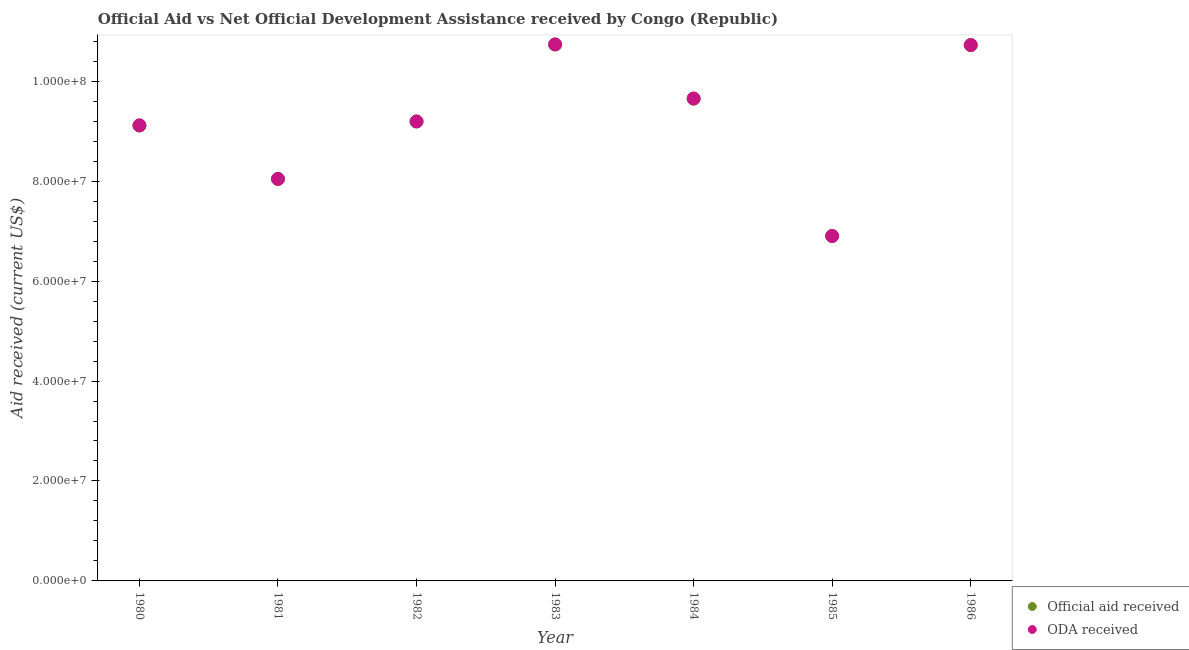How many different coloured dotlines are there?
Keep it short and to the point. 2. Is the number of dotlines equal to the number of legend labels?
Give a very brief answer. Yes. What is the official aid received in 1983?
Provide a short and direct response. 1.07e+08. Across all years, what is the maximum official aid received?
Make the answer very short. 1.07e+08. Across all years, what is the minimum official aid received?
Your response must be concise. 6.90e+07. What is the total oda received in the graph?
Your response must be concise. 6.44e+08. What is the difference between the oda received in 1980 and that in 1984?
Provide a short and direct response. -5.37e+06. What is the difference between the oda received in 1983 and the official aid received in 1986?
Provide a short and direct response. 1.20e+05. What is the average official aid received per year?
Offer a very short reply. 9.20e+07. In the year 1981, what is the difference between the oda received and official aid received?
Your answer should be compact. 0. In how many years, is the official aid received greater than 96000000 US$?
Keep it short and to the point. 3. What is the ratio of the oda received in 1982 to that in 1984?
Provide a succinct answer. 0.95. Is the official aid received in 1981 less than that in 1985?
Give a very brief answer. No. Is the difference between the official aid received in 1981 and 1983 greater than the difference between the oda received in 1981 and 1983?
Ensure brevity in your answer.  No. What is the difference between the highest and the lowest oda received?
Provide a succinct answer. 3.83e+07. Is the sum of the oda received in 1981 and 1983 greater than the maximum official aid received across all years?
Your response must be concise. Yes. Is the oda received strictly greater than the official aid received over the years?
Your answer should be very brief. No. Does the graph contain any zero values?
Give a very brief answer. No. Does the graph contain grids?
Give a very brief answer. No. How many legend labels are there?
Ensure brevity in your answer.  2. What is the title of the graph?
Provide a short and direct response. Official Aid vs Net Official Development Assistance received by Congo (Republic) . What is the label or title of the X-axis?
Your answer should be compact. Year. What is the label or title of the Y-axis?
Your response must be concise. Aid received (current US$). What is the Aid received (current US$) of Official aid received in 1980?
Provide a short and direct response. 9.12e+07. What is the Aid received (current US$) of ODA received in 1980?
Make the answer very short. 9.12e+07. What is the Aid received (current US$) in Official aid received in 1981?
Your answer should be very brief. 8.04e+07. What is the Aid received (current US$) of ODA received in 1981?
Make the answer very short. 8.04e+07. What is the Aid received (current US$) in Official aid received in 1982?
Offer a terse response. 9.19e+07. What is the Aid received (current US$) of ODA received in 1982?
Make the answer very short. 9.19e+07. What is the Aid received (current US$) of Official aid received in 1983?
Ensure brevity in your answer.  1.07e+08. What is the Aid received (current US$) in ODA received in 1983?
Offer a very short reply. 1.07e+08. What is the Aid received (current US$) in Official aid received in 1984?
Your answer should be compact. 9.65e+07. What is the Aid received (current US$) in ODA received in 1984?
Make the answer very short. 9.65e+07. What is the Aid received (current US$) in Official aid received in 1985?
Your answer should be very brief. 6.90e+07. What is the Aid received (current US$) in ODA received in 1985?
Give a very brief answer. 6.90e+07. What is the Aid received (current US$) of Official aid received in 1986?
Provide a short and direct response. 1.07e+08. What is the Aid received (current US$) of ODA received in 1986?
Keep it short and to the point. 1.07e+08. Across all years, what is the maximum Aid received (current US$) in Official aid received?
Your answer should be compact. 1.07e+08. Across all years, what is the maximum Aid received (current US$) in ODA received?
Keep it short and to the point. 1.07e+08. Across all years, what is the minimum Aid received (current US$) of Official aid received?
Provide a succinct answer. 6.90e+07. Across all years, what is the minimum Aid received (current US$) of ODA received?
Provide a short and direct response. 6.90e+07. What is the total Aid received (current US$) in Official aid received in the graph?
Provide a succinct answer. 6.44e+08. What is the total Aid received (current US$) of ODA received in the graph?
Give a very brief answer. 6.44e+08. What is the difference between the Aid received (current US$) of Official aid received in 1980 and that in 1981?
Your answer should be very brief. 1.07e+07. What is the difference between the Aid received (current US$) of ODA received in 1980 and that in 1981?
Keep it short and to the point. 1.07e+07. What is the difference between the Aid received (current US$) of Official aid received in 1980 and that in 1982?
Offer a terse response. -7.90e+05. What is the difference between the Aid received (current US$) in ODA received in 1980 and that in 1982?
Your answer should be very brief. -7.90e+05. What is the difference between the Aid received (current US$) in Official aid received in 1980 and that in 1983?
Your answer should be compact. -1.62e+07. What is the difference between the Aid received (current US$) of ODA received in 1980 and that in 1983?
Your answer should be very brief. -1.62e+07. What is the difference between the Aid received (current US$) in Official aid received in 1980 and that in 1984?
Offer a terse response. -5.37e+06. What is the difference between the Aid received (current US$) of ODA received in 1980 and that in 1984?
Your answer should be compact. -5.37e+06. What is the difference between the Aid received (current US$) in Official aid received in 1980 and that in 1985?
Your answer should be compact. 2.21e+07. What is the difference between the Aid received (current US$) in ODA received in 1980 and that in 1985?
Offer a terse response. 2.21e+07. What is the difference between the Aid received (current US$) of Official aid received in 1980 and that in 1986?
Provide a succinct answer. -1.61e+07. What is the difference between the Aid received (current US$) of ODA received in 1980 and that in 1986?
Your response must be concise. -1.61e+07. What is the difference between the Aid received (current US$) in Official aid received in 1981 and that in 1982?
Offer a very short reply. -1.15e+07. What is the difference between the Aid received (current US$) of ODA received in 1981 and that in 1982?
Your answer should be very brief. -1.15e+07. What is the difference between the Aid received (current US$) in Official aid received in 1981 and that in 1983?
Your response must be concise. -2.69e+07. What is the difference between the Aid received (current US$) of ODA received in 1981 and that in 1983?
Offer a terse response. -2.69e+07. What is the difference between the Aid received (current US$) in Official aid received in 1981 and that in 1984?
Your answer should be compact. -1.61e+07. What is the difference between the Aid received (current US$) in ODA received in 1981 and that in 1984?
Offer a terse response. -1.61e+07. What is the difference between the Aid received (current US$) of Official aid received in 1981 and that in 1985?
Your answer should be compact. 1.14e+07. What is the difference between the Aid received (current US$) in ODA received in 1981 and that in 1985?
Offer a terse response. 1.14e+07. What is the difference between the Aid received (current US$) in Official aid received in 1981 and that in 1986?
Give a very brief answer. -2.68e+07. What is the difference between the Aid received (current US$) of ODA received in 1981 and that in 1986?
Offer a terse response. -2.68e+07. What is the difference between the Aid received (current US$) in Official aid received in 1982 and that in 1983?
Offer a very short reply. -1.54e+07. What is the difference between the Aid received (current US$) in ODA received in 1982 and that in 1983?
Give a very brief answer. -1.54e+07. What is the difference between the Aid received (current US$) of Official aid received in 1982 and that in 1984?
Offer a very short reply. -4.58e+06. What is the difference between the Aid received (current US$) in ODA received in 1982 and that in 1984?
Give a very brief answer. -4.58e+06. What is the difference between the Aid received (current US$) in Official aid received in 1982 and that in 1985?
Your response must be concise. 2.29e+07. What is the difference between the Aid received (current US$) of ODA received in 1982 and that in 1985?
Your response must be concise. 2.29e+07. What is the difference between the Aid received (current US$) in Official aid received in 1982 and that in 1986?
Your response must be concise. -1.53e+07. What is the difference between the Aid received (current US$) in ODA received in 1982 and that in 1986?
Your answer should be compact. -1.53e+07. What is the difference between the Aid received (current US$) of Official aid received in 1983 and that in 1984?
Offer a terse response. 1.08e+07. What is the difference between the Aid received (current US$) in ODA received in 1983 and that in 1984?
Provide a short and direct response. 1.08e+07. What is the difference between the Aid received (current US$) in Official aid received in 1983 and that in 1985?
Make the answer very short. 3.83e+07. What is the difference between the Aid received (current US$) in ODA received in 1983 and that in 1985?
Provide a succinct answer. 3.83e+07. What is the difference between the Aid received (current US$) of Official aid received in 1983 and that in 1986?
Make the answer very short. 1.20e+05. What is the difference between the Aid received (current US$) in ODA received in 1983 and that in 1986?
Offer a terse response. 1.20e+05. What is the difference between the Aid received (current US$) in Official aid received in 1984 and that in 1985?
Make the answer very short. 2.75e+07. What is the difference between the Aid received (current US$) of ODA received in 1984 and that in 1985?
Provide a succinct answer. 2.75e+07. What is the difference between the Aid received (current US$) of Official aid received in 1984 and that in 1986?
Offer a terse response. -1.07e+07. What is the difference between the Aid received (current US$) of ODA received in 1984 and that in 1986?
Provide a short and direct response. -1.07e+07. What is the difference between the Aid received (current US$) of Official aid received in 1985 and that in 1986?
Ensure brevity in your answer.  -3.82e+07. What is the difference between the Aid received (current US$) of ODA received in 1985 and that in 1986?
Your response must be concise. -3.82e+07. What is the difference between the Aid received (current US$) in Official aid received in 1980 and the Aid received (current US$) in ODA received in 1981?
Make the answer very short. 1.07e+07. What is the difference between the Aid received (current US$) in Official aid received in 1980 and the Aid received (current US$) in ODA received in 1982?
Your answer should be very brief. -7.90e+05. What is the difference between the Aid received (current US$) in Official aid received in 1980 and the Aid received (current US$) in ODA received in 1983?
Offer a terse response. -1.62e+07. What is the difference between the Aid received (current US$) in Official aid received in 1980 and the Aid received (current US$) in ODA received in 1984?
Ensure brevity in your answer.  -5.37e+06. What is the difference between the Aid received (current US$) of Official aid received in 1980 and the Aid received (current US$) of ODA received in 1985?
Your answer should be very brief. 2.21e+07. What is the difference between the Aid received (current US$) in Official aid received in 1980 and the Aid received (current US$) in ODA received in 1986?
Offer a very short reply. -1.61e+07. What is the difference between the Aid received (current US$) in Official aid received in 1981 and the Aid received (current US$) in ODA received in 1982?
Your response must be concise. -1.15e+07. What is the difference between the Aid received (current US$) of Official aid received in 1981 and the Aid received (current US$) of ODA received in 1983?
Offer a terse response. -2.69e+07. What is the difference between the Aid received (current US$) of Official aid received in 1981 and the Aid received (current US$) of ODA received in 1984?
Give a very brief answer. -1.61e+07. What is the difference between the Aid received (current US$) in Official aid received in 1981 and the Aid received (current US$) in ODA received in 1985?
Offer a very short reply. 1.14e+07. What is the difference between the Aid received (current US$) of Official aid received in 1981 and the Aid received (current US$) of ODA received in 1986?
Your answer should be very brief. -2.68e+07. What is the difference between the Aid received (current US$) of Official aid received in 1982 and the Aid received (current US$) of ODA received in 1983?
Offer a very short reply. -1.54e+07. What is the difference between the Aid received (current US$) in Official aid received in 1982 and the Aid received (current US$) in ODA received in 1984?
Your answer should be very brief. -4.58e+06. What is the difference between the Aid received (current US$) of Official aid received in 1982 and the Aid received (current US$) of ODA received in 1985?
Offer a terse response. 2.29e+07. What is the difference between the Aid received (current US$) of Official aid received in 1982 and the Aid received (current US$) of ODA received in 1986?
Your response must be concise. -1.53e+07. What is the difference between the Aid received (current US$) in Official aid received in 1983 and the Aid received (current US$) in ODA received in 1984?
Make the answer very short. 1.08e+07. What is the difference between the Aid received (current US$) in Official aid received in 1983 and the Aid received (current US$) in ODA received in 1985?
Provide a short and direct response. 3.83e+07. What is the difference between the Aid received (current US$) in Official aid received in 1984 and the Aid received (current US$) in ODA received in 1985?
Your response must be concise. 2.75e+07. What is the difference between the Aid received (current US$) of Official aid received in 1984 and the Aid received (current US$) of ODA received in 1986?
Your answer should be compact. -1.07e+07. What is the difference between the Aid received (current US$) of Official aid received in 1985 and the Aid received (current US$) of ODA received in 1986?
Give a very brief answer. -3.82e+07. What is the average Aid received (current US$) of Official aid received per year?
Give a very brief answer. 9.20e+07. What is the average Aid received (current US$) of ODA received per year?
Make the answer very short. 9.20e+07. In the year 1982, what is the difference between the Aid received (current US$) in Official aid received and Aid received (current US$) in ODA received?
Your answer should be very brief. 0. In the year 1984, what is the difference between the Aid received (current US$) in Official aid received and Aid received (current US$) in ODA received?
Keep it short and to the point. 0. In the year 1986, what is the difference between the Aid received (current US$) of Official aid received and Aid received (current US$) of ODA received?
Provide a succinct answer. 0. What is the ratio of the Aid received (current US$) of Official aid received in 1980 to that in 1981?
Offer a very short reply. 1.13. What is the ratio of the Aid received (current US$) in ODA received in 1980 to that in 1981?
Make the answer very short. 1.13. What is the ratio of the Aid received (current US$) of Official aid received in 1980 to that in 1983?
Your answer should be very brief. 0.85. What is the ratio of the Aid received (current US$) of ODA received in 1980 to that in 1983?
Give a very brief answer. 0.85. What is the ratio of the Aid received (current US$) in ODA received in 1980 to that in 1984?
Your answer should be very brief. 0.94. What is the ratio of the Aid received (current US$) of Official aid received in 1980 to that in 1985?
Your answer should be very brief. 1.32. What is the ratio of the Aid received (current US$) of ODA received in 1980 to that in 1985?
Keep it short and to the point. 1.32. What is the ratio of the Aid received (current US$) in Official aid received in 1980 to that in 1986?
Make the answer very short. 0.85. What is the ratio of the Aid received (current US$) of Official aid received in 1981 to that in 1982?
Provide a succinct answer. 0.87. What is the ratio of the Aid received (current US$) in ODA received in 1981 to that in 1982?
Offer a terse response. 0.87. What is the ratio of the Aid received (current US$) of Official aid received in 1981 to that in 1983?
Your answer should be compact. 0.75. What is the ratio of the Aid received (current US$) of ODA received in 1981 to that in 1983?
Make the answer very short. 0.75. What is the ratio of the Aid received (current US$) in Official aid received in 1981 to that in 1984?
Provide a short and direct response. 0.83. What is the ratio of the Aid received (current US$) of ODA received in 1981 to that in 1984?
Your response must be concise. 0.83. What is the ratio of the Aid received (current US$) in Official aid received in 1981 to that in 1985?
Provide a short and direct response. 1.17. What is the ratio of the Aid received (current US$) in ODA received in 1981 to that in 1985?
Ensure brevity in your answer.  1.17. What is the ratio of the Aid received (current US$) of Official aid received in 1981 to that in 1986?
Offer a very short reply. 0.75. What is the ratio of the Aid received (current US$) in ODA received in 1981 to that in 1986?
Offer a terse response. 0.75. What is the ratio of the Aid received (current US$) in Official aid received in 1982 to that in 1983?
Your response must be concise. 0.86. What is the ratio of the Aid received (current US$) of ODA received in 1982 to that in 1983?
Your answer should be very brief. 0.86. What is the ratio of the Aid received (current US$) of Official aid received in 1982 to that in 1984?
Make the answer very short. 0.95. What is the ratio of the Aid received (current US$) of ODA received in 1982 to that in 1984?
Your answer should be compact. 0.95. What is the ratio of the Aid received (current US$) in Official aid received in 1982 to that in 1985?
Your answer should be very brief. 1.33. What is the ratio of the Aid received (current US$) of ODA received in 1982 to that in 1985?
Your response must be concise. 1.33. What is the ratio of the Aid received (current US$) of Official aid received in 1982 to that in 1986?
Offer a very short reply. 0.86. What is the ratio of the Aid received (current US$) in ODA received in 1982 to that in 1986?
Provide a short and direct response. 0.86. What is the ratio of the Aid received (current US$) of Official aid received in 1983 to that in 1984?
Make the answer very short. 1.11. What is the ratio of the Aid received (current US$) of ODA received in 1983 to that in 1984?
Make the answer very short. 1.11. What is the ratio of the Aid received (current US$) of Official aid received in 1983 to that in 1985?
Offer a very short reply. 1.56. What is the ratio of the Aid received (current US$) of ODA received in 1983 to that in 1985?
Keep it short and to the point. 1.56. What is the ratio of the Aid received (current US$) in Official aid received in 1983 to that in 1986?
Provide a succinct answer. 1. What is the ratio of the Aid received (current US$) of ODA received in 1983 to that in 1986?
Offer a terse response. 1. What is the ratio of the Aid received (current US$) of Official aid received in 1984 to that in 1985?
Keep it short and to the point. 1.4. What is the ratio of the Aid received (current US$) of ODA received in 1984 to that in 1985?
Your answer should be compact. 1.4. What is the ratio of the Aid received (current US$) in Official aid received in 1984 to that in 1986?
Provide a short and direct response. 0.9. What is the ratio of the Aid received (current US$) of ODA received in 1984 to that in 1986?
Offer a very short reply. 0.9. What is the ratio of the Aid received (current US$) of Official aid received in 1985 to that in 1986?
Offer a terse response. 0.64. What is the ratio of the Aid received (current US$) in ODA received in 1985 to that in 1986?
Offer a terse response. 0.64. What is the difference between the highest and the second highest Aid received (current US$) of ODA received?
Your response must be concise. 1.20e+05. What is the difference between the highest and the lowest Aid received (current US$) in Official aid received?
Your response must be concise. 3.83e+07. What is the difference between the highest and the lowest Aid received (current US$) in ODA received?
Ensure brevity in your answer.  3.83e+07. 